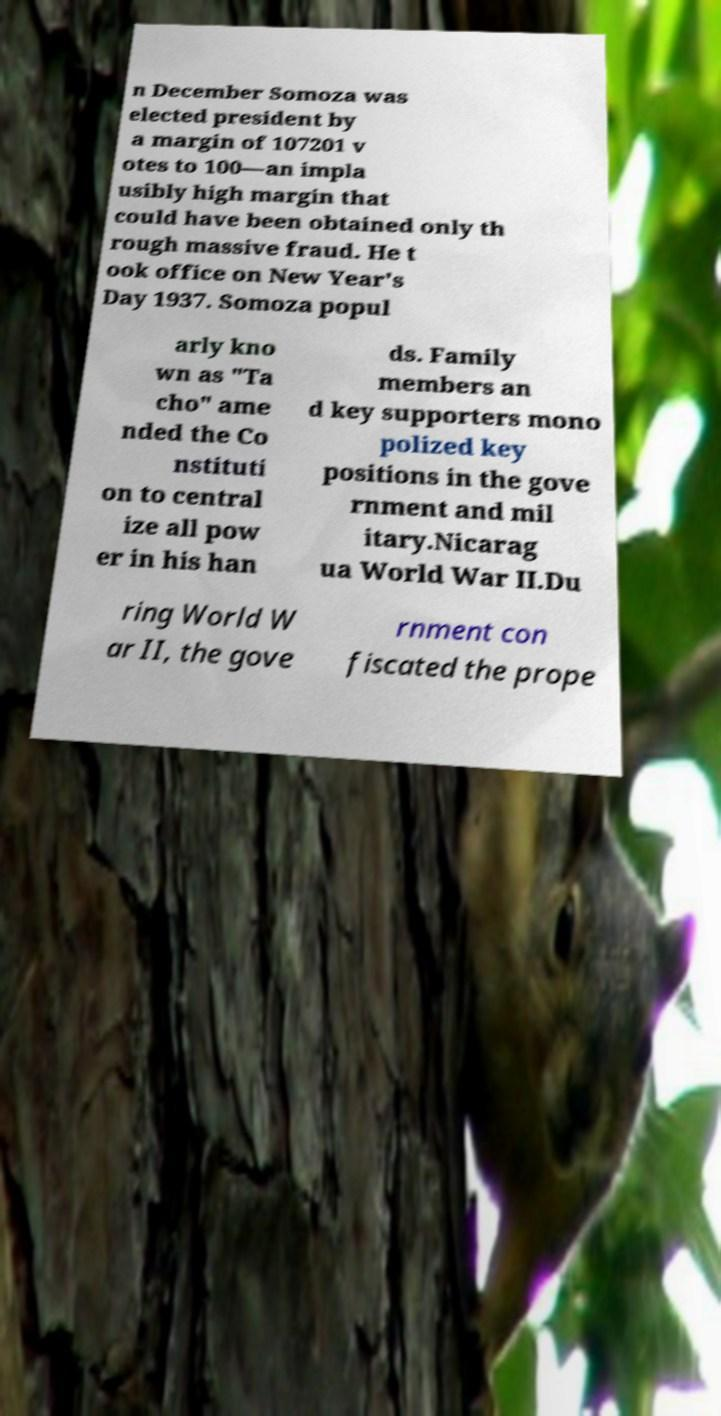Please read and relay the text visible in this image. What does it say? n December Somoza was elected president by a margin of 107201 v otes to 100—an impla usibly high margin that could have been obtained only th rough massive fraud. He t ook office on New Year's Day 1937. Somoza popul arly kno wn as "Ta cho" ame nded the Co nstituti on to central ize all pow er in his han ds. Family members an d key supporters mono polized key positions in the gove rnment and mil itary.Nicarag ua World War II.Du ring World W ar II, the gove rnment con fiscated the prope 